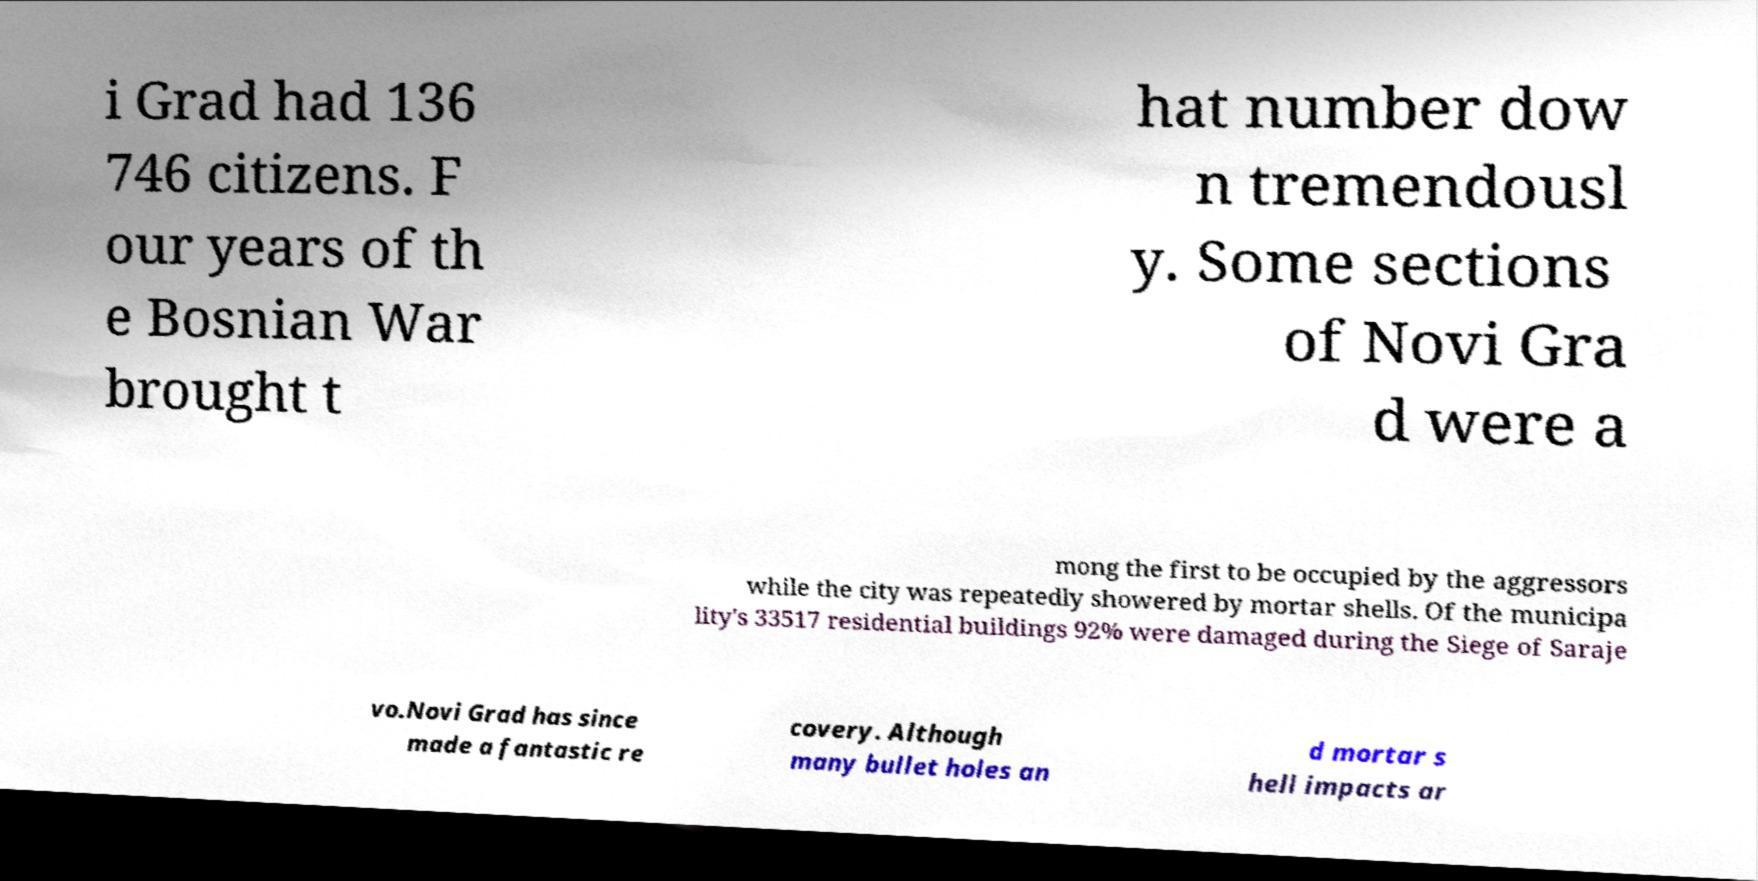What messages or text are displayed in this image? I need them in a readable, typed format. i Grad had 136 746 citizens. F our years of th e Bosnian War brought t hat number dow n tremendousl y. Some sections of Novi Gra d were a mong the first to be occupied by the aggressors while the city was repeatedly showered by mortar shells. Of the municipa lity's 33517 residential buildings 92% were damaged during the Siege of Saraje vo.Novi Grad has since made a fantastic re covery. Although many bullet holes an d mortar s hell impacts ar 